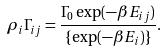Convert formula to latex. <formula><loc_0><loc_0><loc_500><loc_500>\rho _ { i } \Gamma _ { i j } = \frac { \Gamma _ { 0 } \exp ( - \beta E _ { i j } ) } { \{ \exp ( - \beta E _ { i } ) \} } .</formula> 